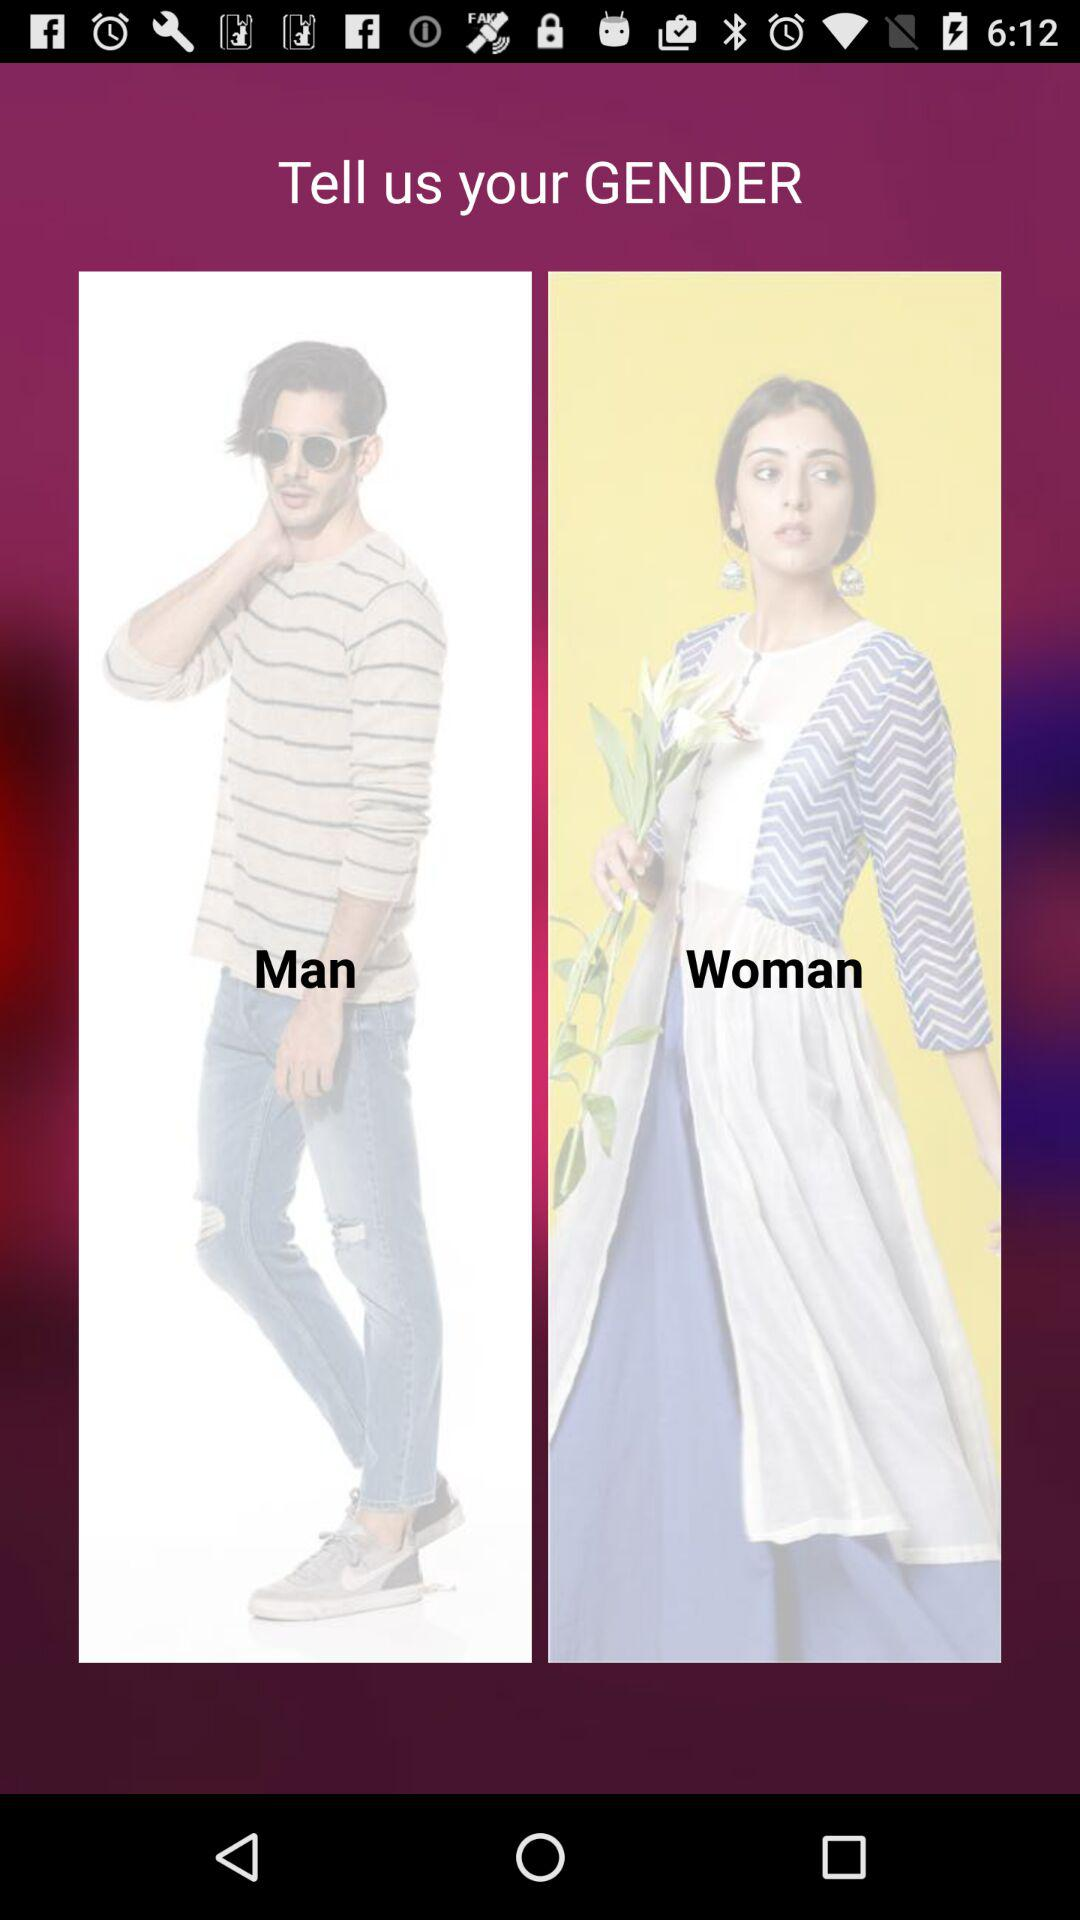Which options are given for selecting the gender? The given options are "Man" and "Woman". 